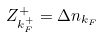Convert formula to latex. <formula><loc_0><loc_0><loc_500><loc_500>Z _ { k _ { F } ^ { + } } ^ { + } = \Delta n _ { k _ { F } }</formula> 